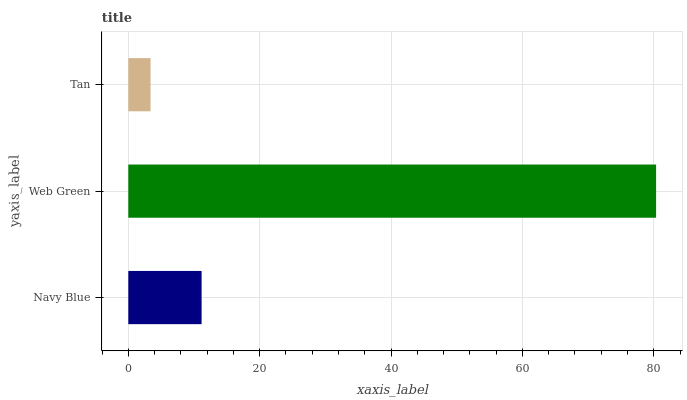Is Tan the minimum?
Answer yes or no. Yes. Is Web Green the maximum?
Answer yes or no. Yes. Is Web Green the minimum?
Answer yes or no. No. Is Tan the maximum?
Answer yes or no. No. Is Web Green greater than Tan?
Answer yes or no. Yes. Is Tan less than Web Green?
Answer yes or no. Yes. Is Tan greater than Web Green?
Answer yes or no. No. Is Web Green less than Tan?
Answer yes or no. No. Is Navy Blue the high median?
Answer yes or no. Yes. Is Navy Blue the low median?
Answer yes or no. Yes. Is Web Green the high median?
Answer yes or no. No. Is Web Green the low median?
Answer yes or no. No. 